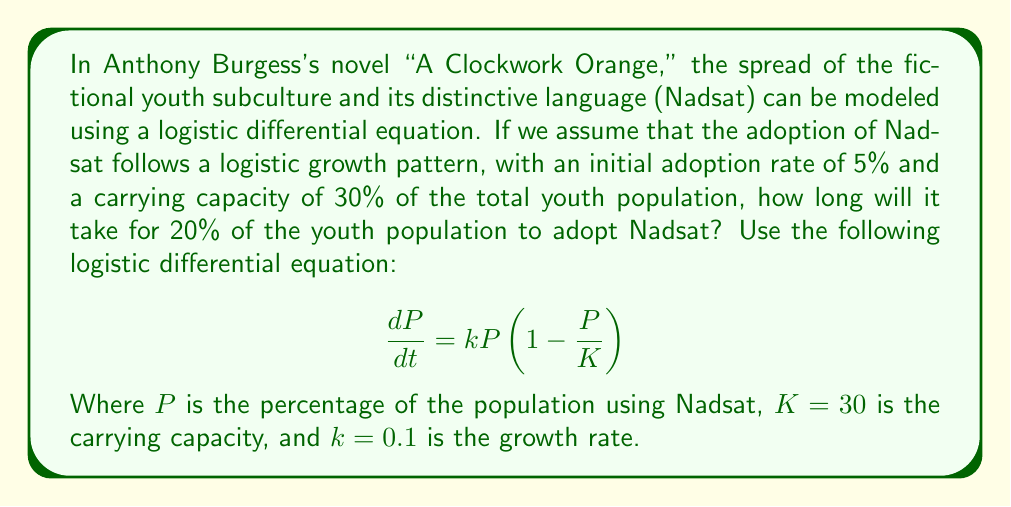Could you help me with this problem? To solve this problem, we need to use the logistic growth model and its solution. The logistic differential equation given is:

$$\frac{dP}{dt} = kP(1-\frac{P}{K})$$

The solution to this equation is:

$$P(t) = \frac{K}{1 + (\frac{K}{P_0} - 1)e^{-kt}}$$

Where $P_0$ is the initial population percentage.

Given:
- Initial adoption rate: $P_0 = 5\%$
- Carrying capacity: $K = 30\%$
- Growth rate: $k = 0.1$
- Target adoption rate: $P(t) = 20\%$

We need to solve for $t$ when $P(t) = 20\%$:

$$20 = \frac{30}{1 + (\frac{30}{5} - 1)e^{-0.1t}}$$

Simplifying:

$$20 = \frac{30}{1 + 5e^{-0.1t}}$$

Solving for $t$:

$$1 + 5e^{-0.1t} = \frac{30}{20} = 1.5$$

$$5e^{-0.1t} = 0.5$$

$$e^{-0.1t} = 0.1$$

$$-0.1t = \ln(0.1)$$

$$t = -\frac{\ln(0.1)}{0.1} \approx 23.03$$

Therefore, it will take approximately 23.03 time units for 20% of the youth population to adopt Nadsat.
Answer: $t \approx 23.03$ time units 